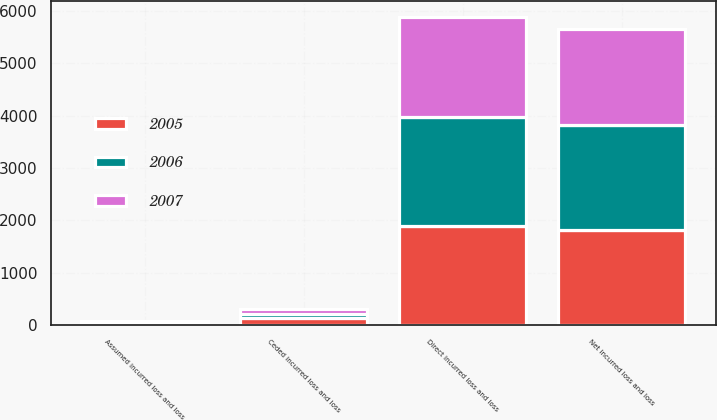Convert chart to OTSL. <chart><loc_0><loc_0><loc_500><loc_500><stacked_bar_chart><ecel><fcel>Direct incurred loss and loss<fcel>Assumed incurred loss and loss<fcel>Ceded incurred loss and loss<fcel>Net incurred loss and loss<nl><fcel>2007<fcel>1922<fcel>17<fcel>107<fcel>1832<nl><fcel>2006<fcel>2072<fcel>13<fcel>77<fcel>2008<nl><fcel>2005<fcel>1898<fcel>40<fcel>126<fcel>1812<nl></chart> 